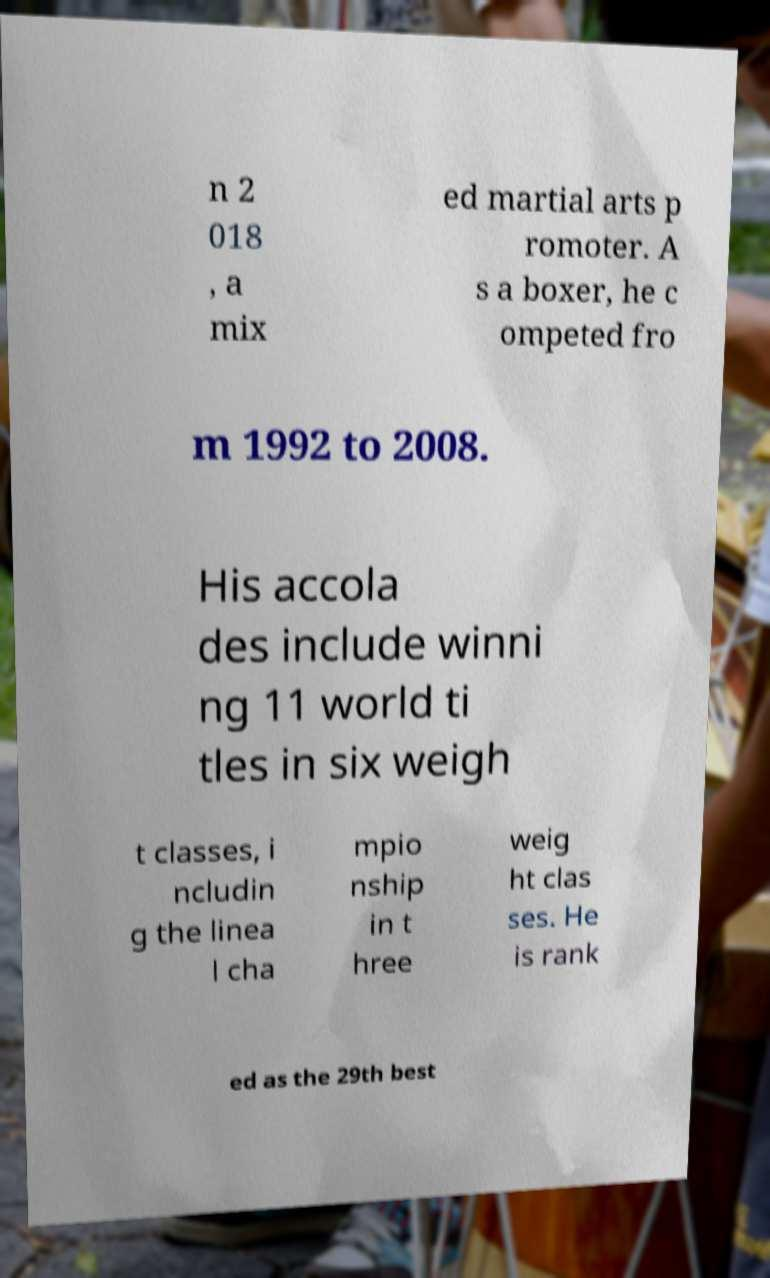Can you read and provide the text displayed in the image?This photo seems to have some interesting text. Can you extract and type it out for me? n 2 018 , a mix ed martial arts p romoter. A s a boxer, he c ompeted fro m 1992 to 2008. His accola des include winni ng 11 world ti tles in six weigh t classes, i ncludin g the linea l cha mpio nship in t hree weig ht clas ses. He is rank ed as the 29th best 